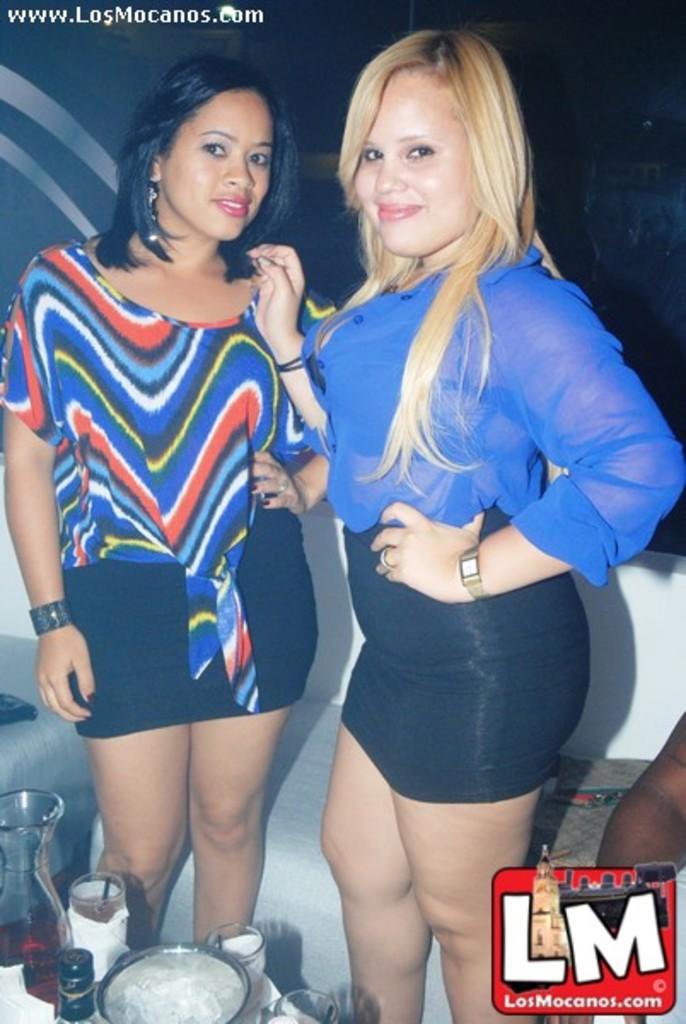What web address can you find these pictures at?
Your answer should be very brief. Losmocanos.com. What are the big white letters at the bottom?
Your response must be concise. Lm. 